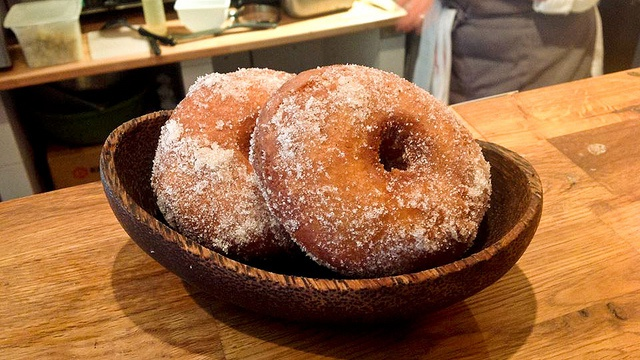Describe the objects in this image and their specific colors. I can see bowl in black, tan, maroon, and brown tones, donut in black, salmon, tan, and ivory tones, people in black, gray, maroon, and darkgray tones, spoon in black and olive tones, and knife in black, darkgreen, and gray tones in this image. 